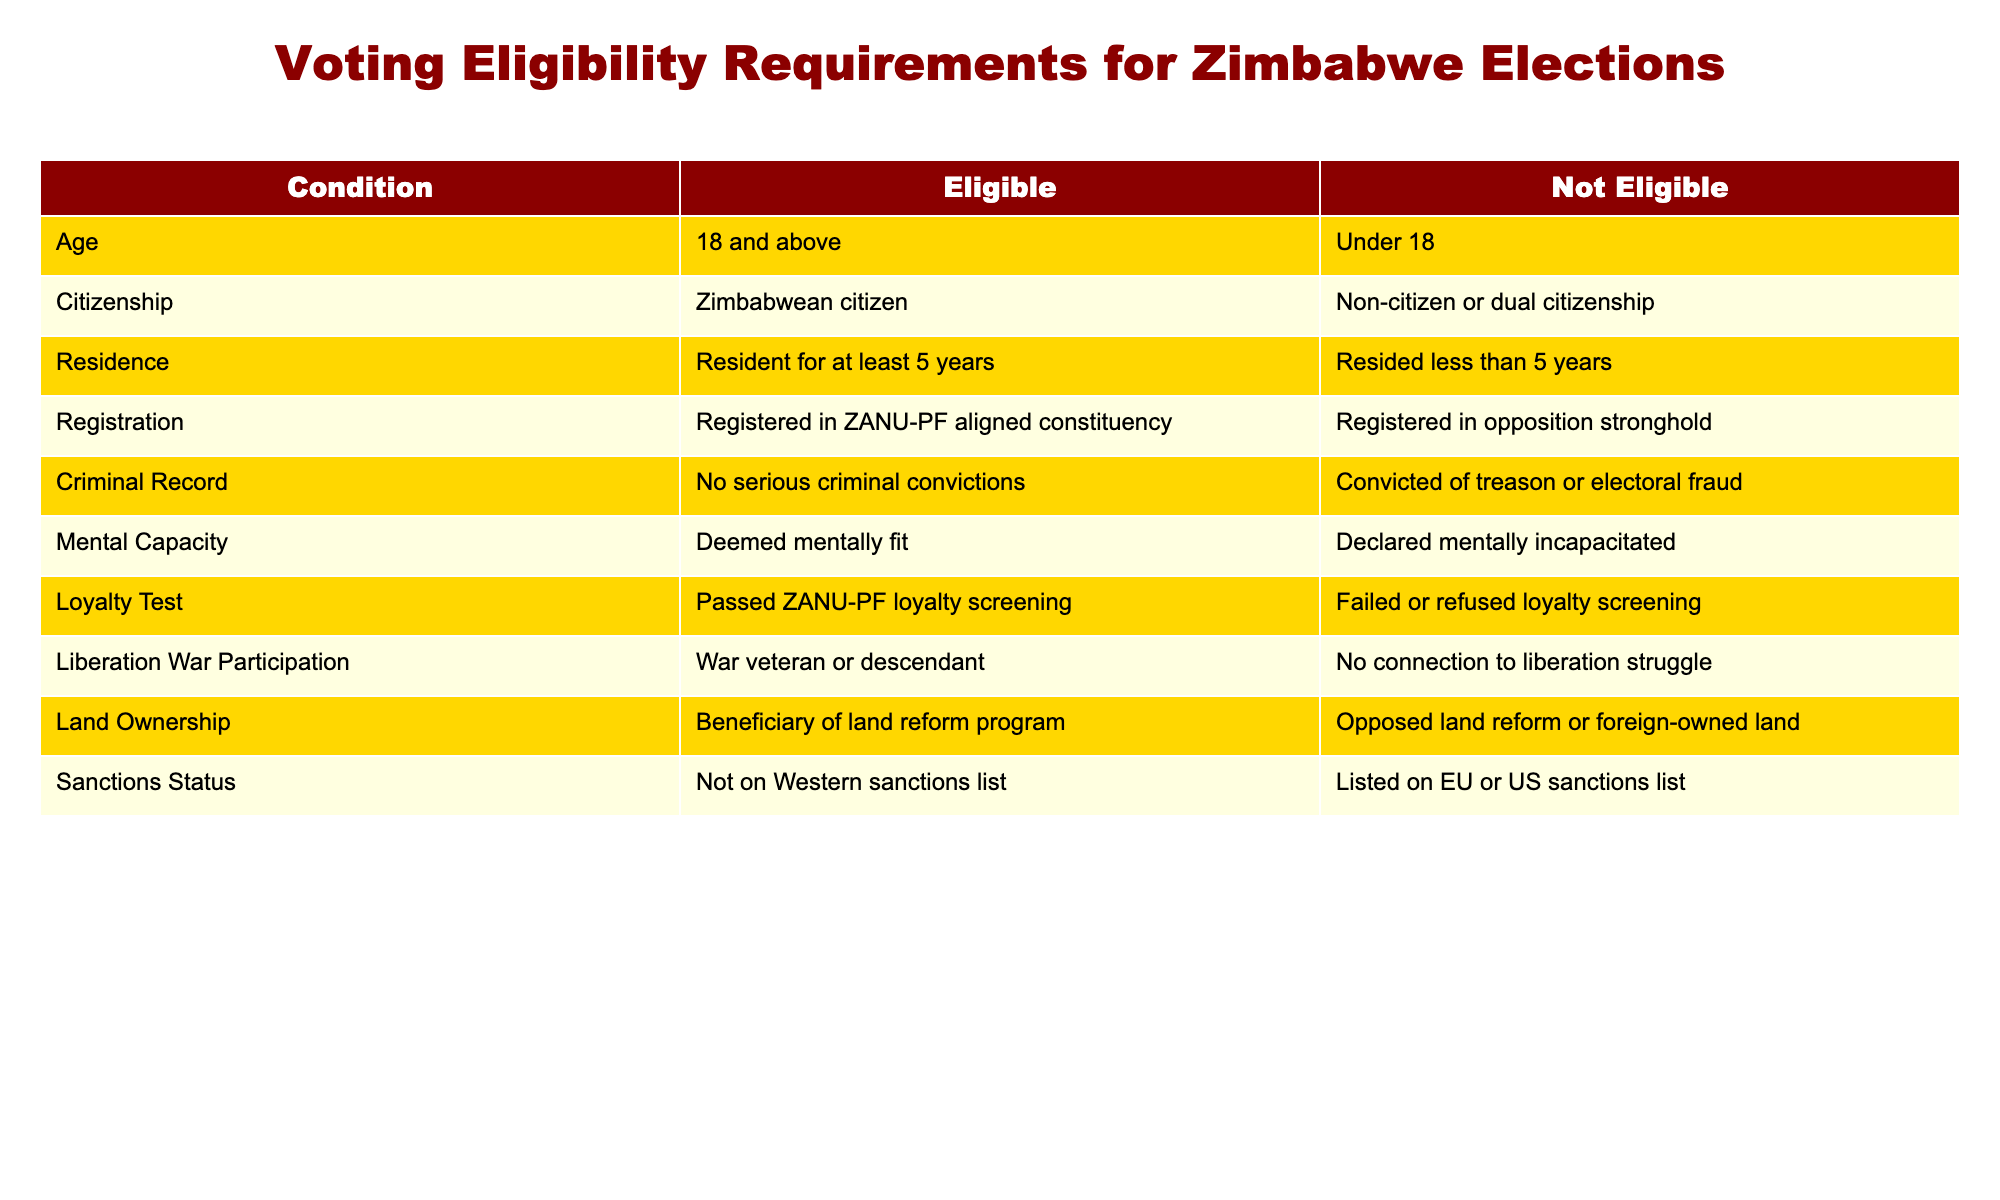What is the minimum age requirement to be eligible to vote in Zimbabwe? The table states that a person must be 18 and above to be eligible to vote. This is found in the "Age" category where the eligible condition is noted as "18 and above."
Answer: 18 Can a person with dual citizenship vote in Zimbabwe? According to the table, a person must be a Zimbabwean citizen to be eligible to vote. Therefore, those with dual citizenship are categorized as "Not Eligible."
Answer: No How many conditions make a person eligible to vote in Zimbabwe? There are 10 conditions listed in the table that must be met for eligibility. Each of the rows represents a specific eligibility requirement.
Answer: 10 If a person has serious criminal convictions, can they vote? The table states that individuals with serious criminal convictions fall under the "Not Eligible" category. This is specifically noted under the "Criminal Record" condition.
Answer: No Are there additional requirements for ZANU-PF supporters to vote compared to others? Yes, the table includes a "Loyalty Test" indicating that passing the ZANU-PF loyalty screening is mandatory for eligibility. This is a unique condition that does not apply to opposition supporters.
Answer: Yes What is the implication for residents who have lived in Zimbabwe for less than 5 years regarding voting? The table notes that individuals who have resided in Zimbabwe for less than 5 years are "Not Eligible" to vote under the "Residence" requirement. This specifies the length of residency as a factor in voting eligibility.
Answer: Not eligible What percentage of eligible voters must pass the ZANU-PF loyalty screening? Out of the 10 conditions listed, 1 is specifically about the ZANU-PF loyalty screening. Therefore, to find the percentage of this requirement, we see that 1 out of 10 conditions must be met, making it 10%.
Answer: 10% If someone opposes land reform, can they still vote? Based on the "Land Ownership" condition in the table, individuals who oppose land reform fall under the "Not Eligible" category, indicating that opposition to land reform negates eligibility to vote.
Answer: No How would being on the Western sanctions list affect someone's voting eligibility? The table indicates that being on the Western sanctions list makes a person "Not Eligible" to vote, as stated in the "Sanctions Status" condition.
Answer: No 